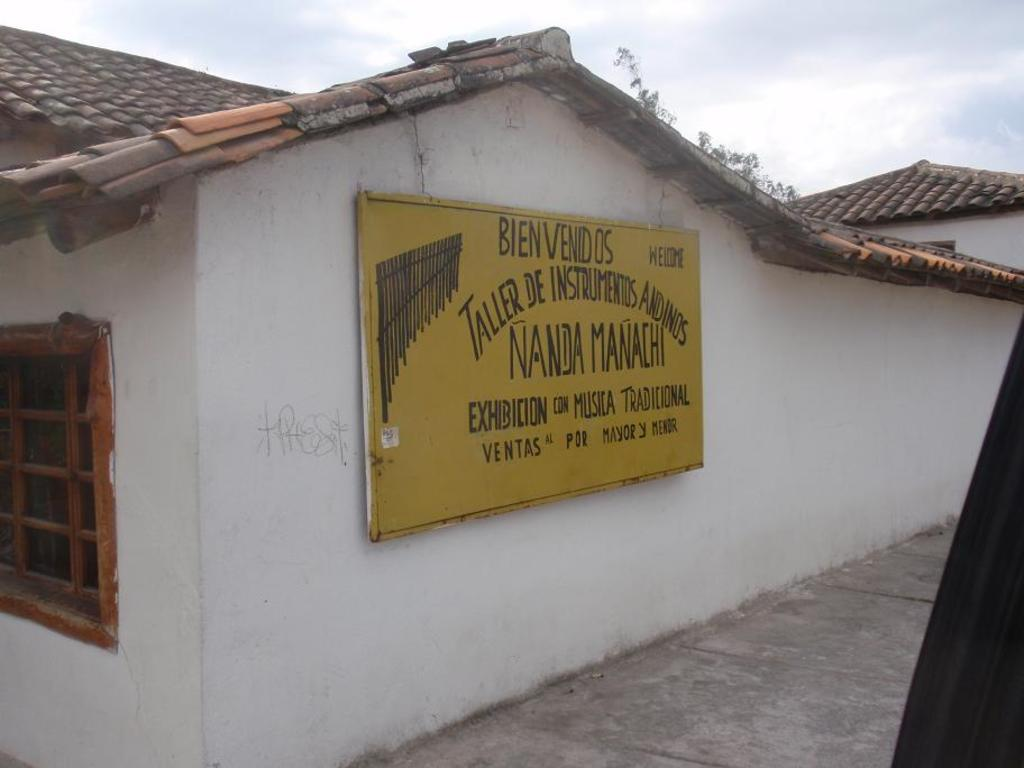<image>
Render a clear and concise summary of the photo. a white house with bienvenidos in black and yellow on it 